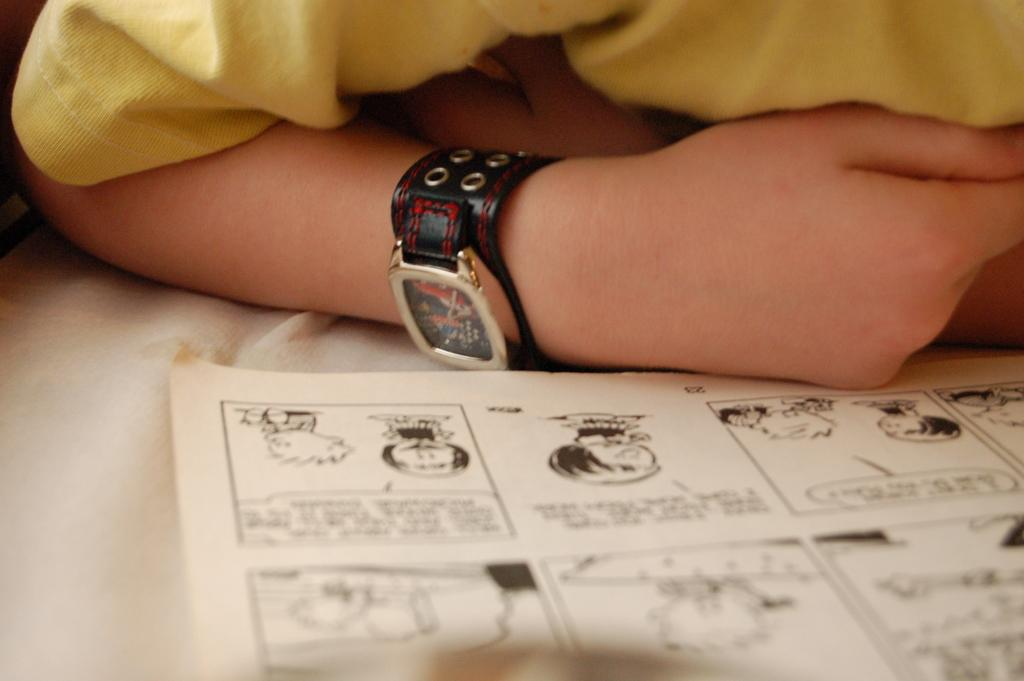What is located at the bottom of the image? There is a chart at the bottom of the image. What can be found on the chart? The chart contains paintings and texts. Is there anyone near the chart in the image? Yes, there is a person beside the chart. What is the person wearing on their upper body? The person is wearing a yellow T-shirt. Can you describe any accessories the person is wearing? The person is wearing a watch. How many boats are visible in the image? There are no boats present in the image. What type of curtain is hanging near the chart? There is no curtain present in the image. 